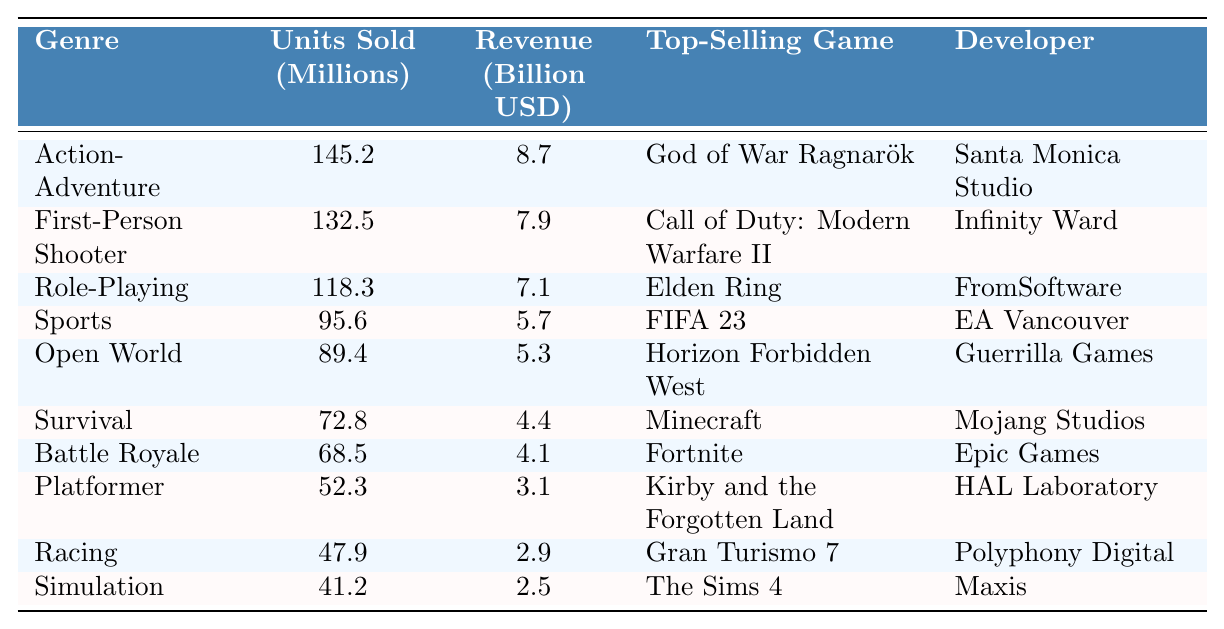What is the top-selling game in the Action-Adventure genre? The table lists "God of War Ragnarök" as the top-selling game under the Action-Adventure genre.
Answer: God of War Ragnarök How many units were sold in the First-Person Shooter genre? Referring to the table, the Units Sold for the First-Person Shooter genre is 132.5 million.
Answer: 132.5 million Which genre had the highest revenue, and what was that revenue? The Action-Adventure genre had the highest revenue at 8.7 billion USD, as indicated in the table.
Answer: Action-Adventure genre: 8.7 billion USD What is the difference in units sold between the Role-Playing and Sports genres? The Role-Playing genre sold 118.3 million units, while the Sports genre sold 95.6 million units. The difference is 118.3 - 95.6 = 22.7 million units.
Answer: 22.7 million units Is the revenue for the Racing genre greater than that of the Survival genre? The Racing genre generated 2.9 billion USD and the Survival genre generated 4.4 billion USD, indicating that Racing has less revenue than Survival. Therefore, the statement is false.
Answer: No What is the average revenue of the top three video game genres by units sold? The top three genres (Action-Adventure, First-Person Shooter, and Role-Playing) have revenues of 8.7 billion, 7.9 billion, and 7.1 billion respectively. The average is (8.7 + 7.9 + 7.1) / 3 = 7.933 billion USD.
Answer: 7.933 billion USD Which genre had the lowest units sold, and how many units did it sell? The genre with the lowest units sold is Simulation, which sold 41.2 million units according to the table data.
Answer: Simulation genre: 41.2 million units How many more units were sold in the Sports genre compared to the Racing genre? The Sports genre sold 95.6 million units, while the Racing genre sold 47.9 million. The difference is 95.6 - 47.9 = 47.7 million units.
Answer: 47.7 million units Are there any genres that sold more than 100 million units? Yes, the genres Action-Adventure, First-Person Shooter, and Role-Playing all sold more than 100 million units.
Answer: Yes If we combine the units sold from the Open World and Survival genres, what is the total? The Open World genre sold 89.4 million units and the Survival genre sold 72.8 million units. The total is 89.4 + 72.8 = 162.2 million units.
Answer: 162.2 million units 